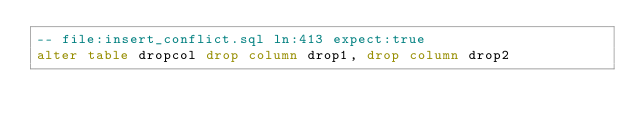<code> <loc_0><loc_0><loc_500><loc_500><_SQL_>-- file:insert_conflict.sql ln:413 expect:true
alter table dropcol drop column drop1, drop column drop2
</code> 